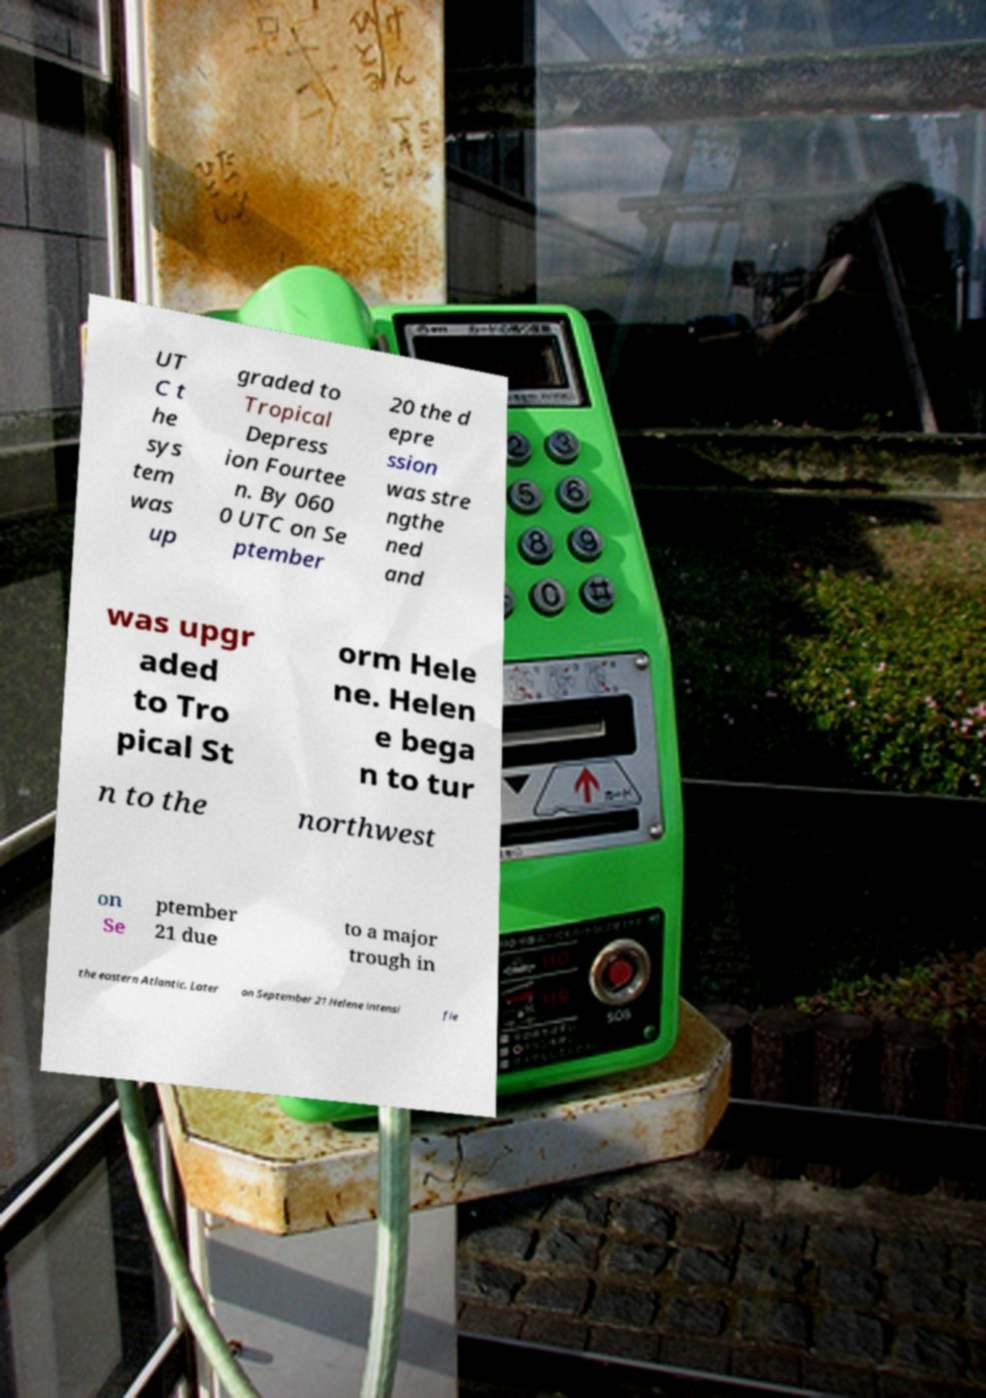For documentation purposes, I need the text within this image transcribed. Could you provide that? UT C t he sys tem was up graded to Tropical Depress ion Fourtee n. By 060 0 UTC on Se ptember 20 the d epre ssion was stre ngthe ned and was upgr aded to Tro pical St orm Hele ne. Helen e bega n to tur n to the northwest on Se ptember 21 due to a major trough in the eastern Atlantic. Later on September 21 Helene intensi fie 